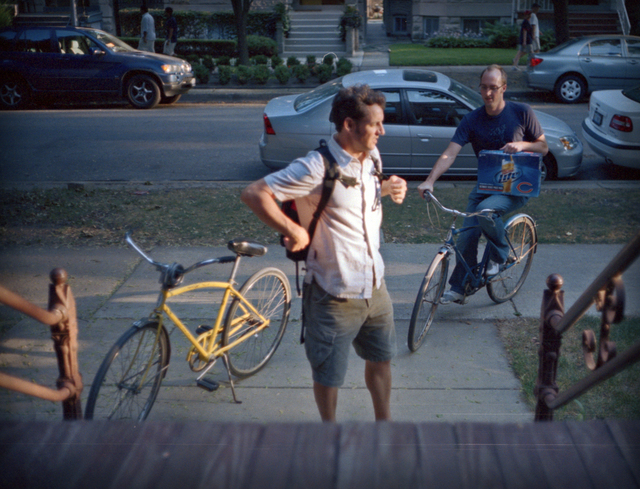Can you describe the atmosphere or mood conveyed by the setting and activities in the image? The image conveys a laid-back and friendly atmosphere, evidenced by the open postures and casual attire of the people. The residential setting, with trees lining the street and a serene neighborhood vibe, enhances the sense of a peaceful, communal environment. The activities, such as adjusting a backpack and casually holding a bike, align with everyday, unhurried life, emphasizing a mood of comfort and ease. 